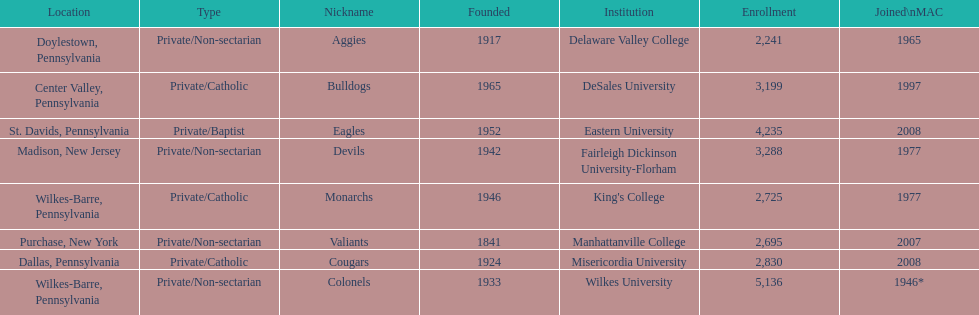What is the enrollment number of misericordia university? 2,830. 